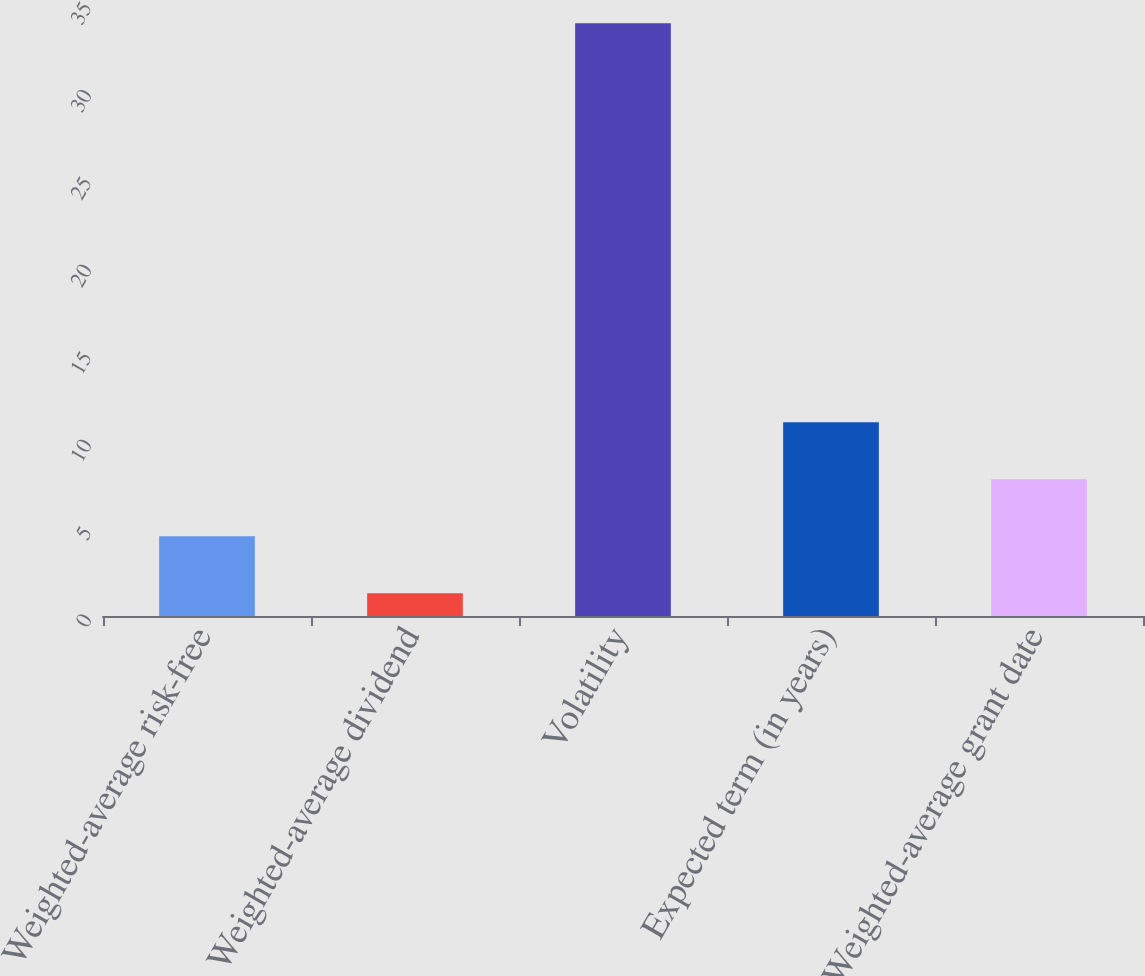<chart> <loc_0><loc_0><loc_500><loc_500><bar_chart><fcel>Weighted-average risk-free<fcel>Weighted-average dividend<fcel>Volatility<fcel>Expected term (in years)<fcel>Weighted-average grant date<nl><fcel>4.56<fcel>1.3<fcel>33.9<fcel>11.08<fcel>7.82<nl></chart> 